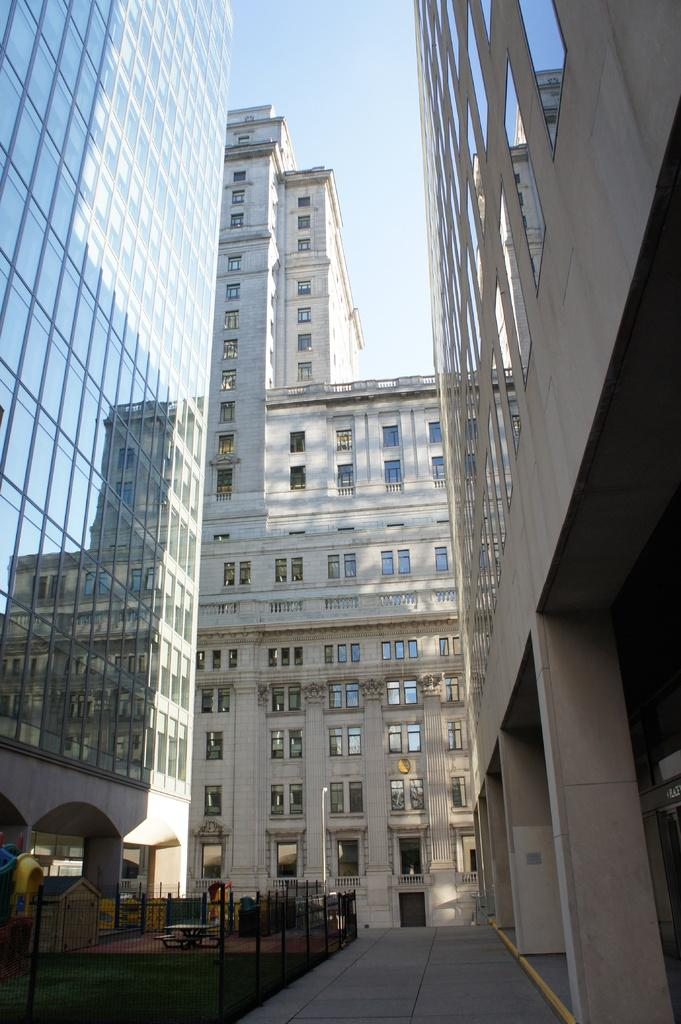What type of structures are present in the image? There are buildings in the image. What colors are the buildings? The buildings are in white and cream colors. What else can be seen in the image besides the buildings? There is fencing in the image. What is visible in the background of the image? The sky is visible in the image and is white in color. What type of farm animals can be seen in the image? There are no farm animals present in the image. Is the image depicting a prison? There is no indication in the image that it is depicting a prison. Who is the writer featured in the image? There is no writer present in the image. 